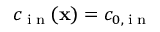Convert formula to latex. <formula><loc_0><loc_0><loc_500><loc_500>c _ { i n } ( x ) = c _ { 0 , i n }</formula> 